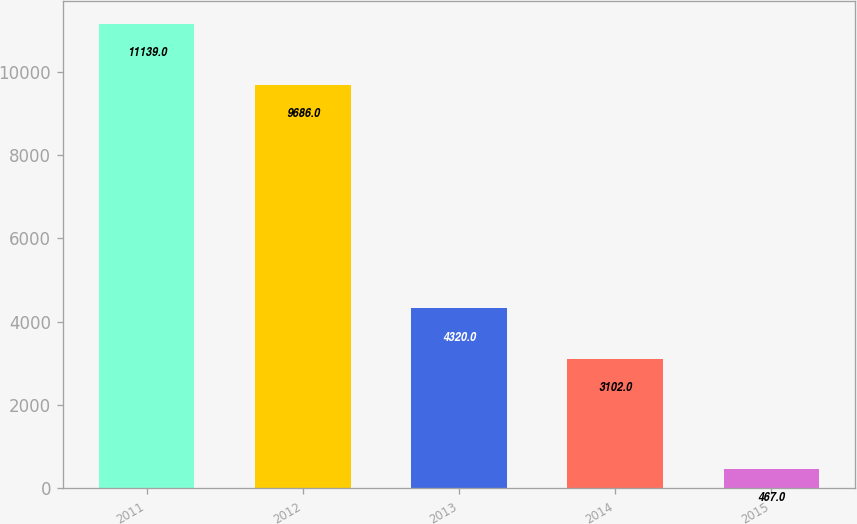<chart> <loc_0><loc_0><loc_500><loc_500><bar_chart><fcel>2011<fcel>2012<fcel>2013<fcel>2014<fcel>2015<nl><fcel>11139<fcel>9686<fcel>4320<fcel>3102<fcel>467<nl></chart> 